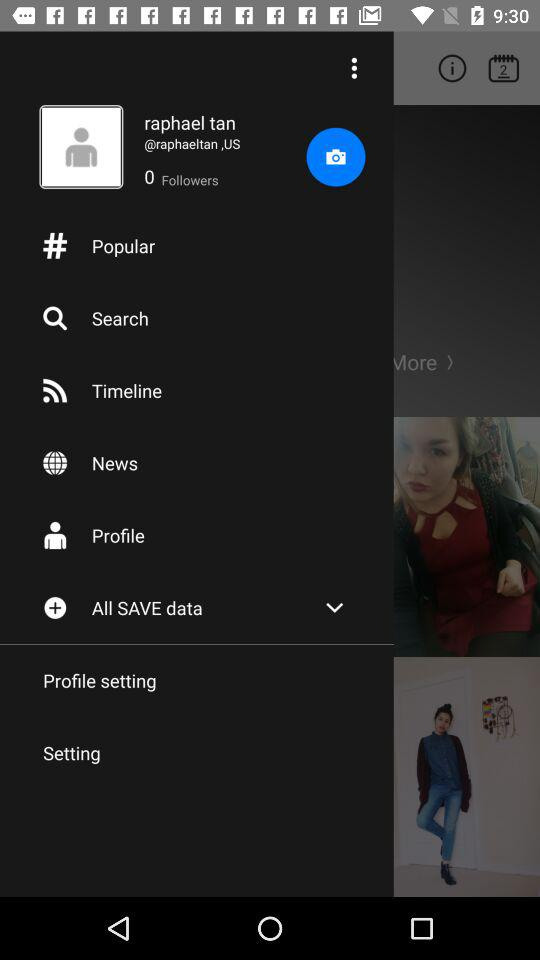How many followers are there? There are 0 followers. 